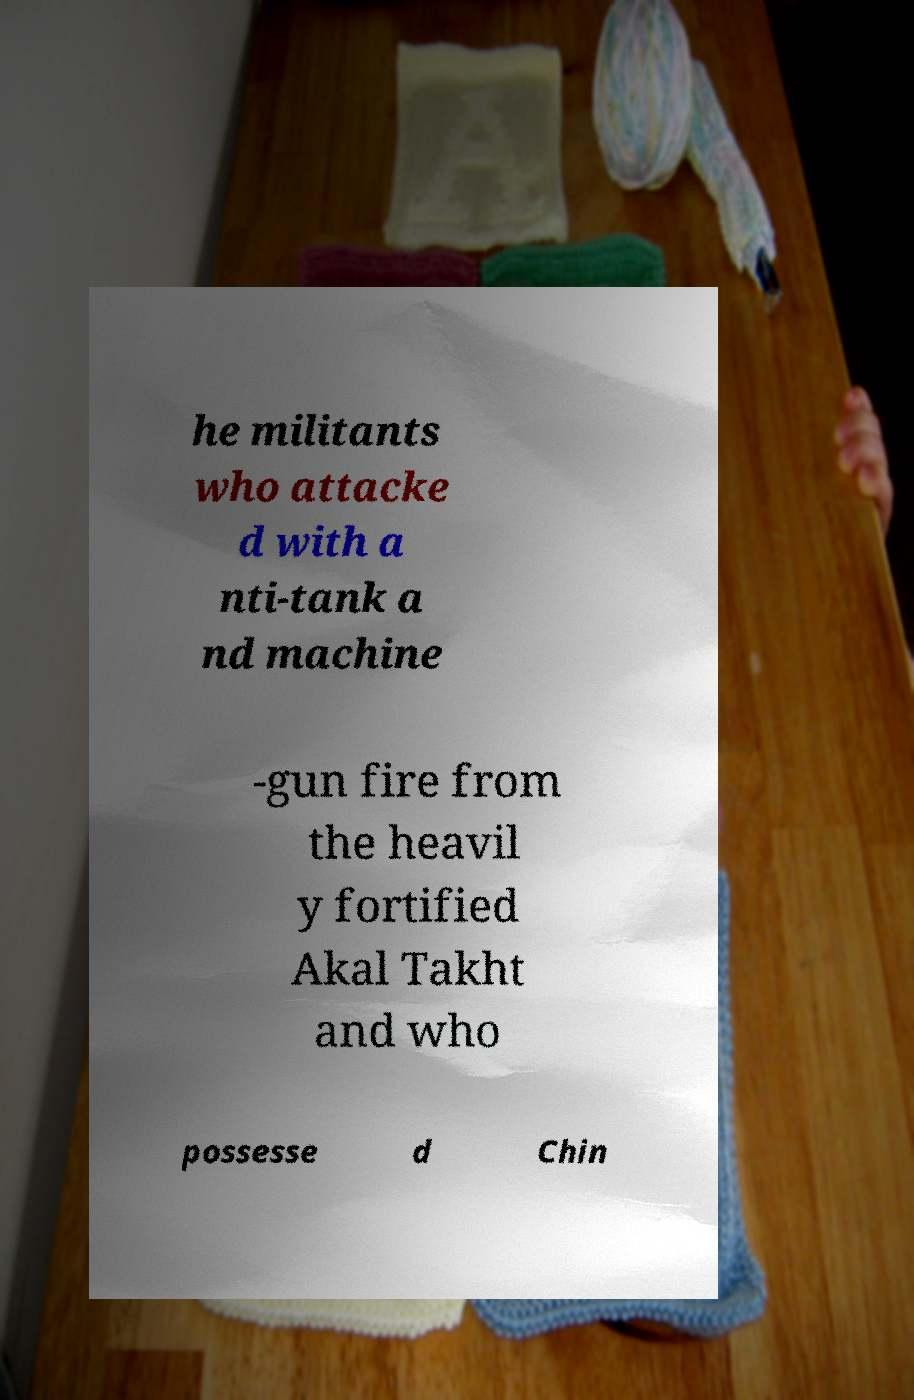There's text embedded in this image that I need extracted. Can you transcribe it verbatim? he militants who attacke d with a nti-tank a nd machine -gun fire from the heavil y fortified Akal Takht and who possesse d Chin 